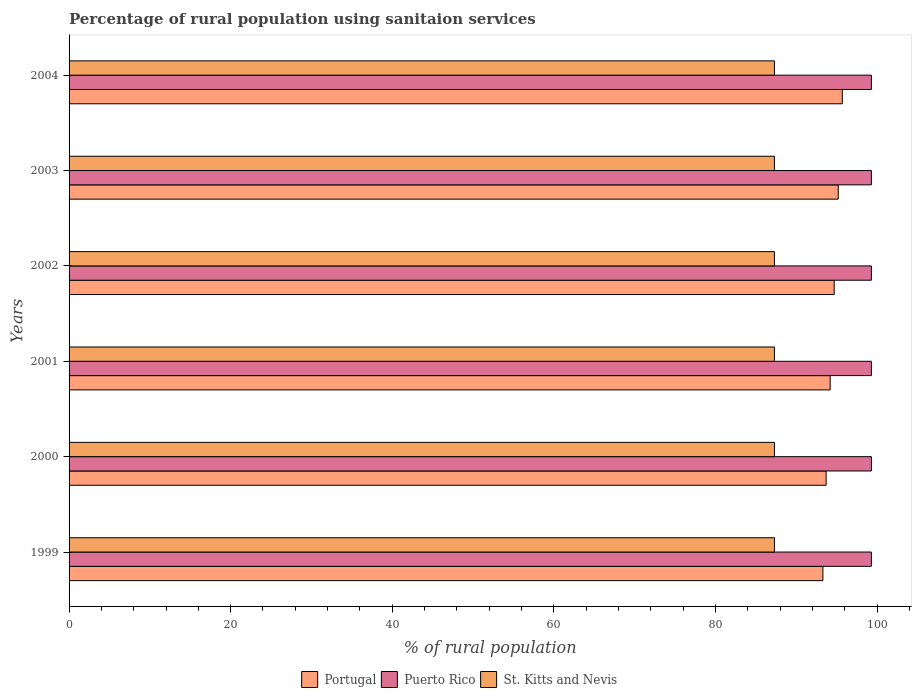How many different coloured bars are there?
Give a very brief answer. 3. How many groups of bars are there?
Your answer should be very brief. 6. Are the number of bars per tick equal to the number of legend labels?
Give a very brief answer. Yes. How many bars are there on the 4th tick from the top?
Provide a succinct answer. 3. In how many cases, is the number of bars for a given year not equal to the number of legend labels?
Offer a very short reply. 0. What is the percentage of rural population using sanitaion services in Portugal in 2002?
Your response must be concise. 94.7. Across all years, what is the maximum percentage of rural population using sanitaion services in Portugal?
Ensure brevity in your answer.  95.7. Across all years, what is the minimum percentage of rural population using sanitaion services in St. Kitts and Nevis?
Make the answer very short. 87.3. In which year was the percentage of rural population using sanitaion services in Puerto Rico minimum?
Keep it short and to the point. 1999. What is the total percentage of rural population using sanitaion services in Puerto Rico in the graph?
Make the answer very short. 595.8. What is the difference between the percentage of rural population using sanitaion services in Portugal in 1999 and that in 2004?
Your answer should be compact. -2.4. What is the difference between the percentage of rural population using sanitaion services in St. Kitts and Nevis in 1999 and the percentage of rural population using sanitaion services in Portugal in 2001?
Ensure brevity in your answer.  -6.9. What is the average percentage of rural population using sanitaion services in Puerto Rico per year?
Offer a terse response. 99.3. In the year 2003, what is the difference between the percentage of rural population using sanitaion services in Portugal and percentage of rural population using sanitaion services in St. Kitts and Nevis?
Your answer should be very brief. 7.9. What is the ratio of the percentage of rural population using sanitaion services in St. Kitts and Nevis in 2001 to that in 2003?
Your answer should be very brief. 1. Is the difference between the percentage of rural population using sanitaion services in Portugal in 1999 and 2003 greater than the difference between the percentage of rural population using sanitaion services in St. Kitts and Nevis in 1999 and 2003?
Ensure brevity in your answer.  No. What is the difference between the highest and the second highest percentage of rural population using sanitaion services in Puerto Rico?
Offer a terse response. 0. What is the difference between the highest and the lowest percentage of rural population using sanitaion services in Portugal?
Give a very brief answer. 2.4. In how many years, is the percentage of rural population using sanitaion services in St. Kitts and Nevis greater than the average percentage of rural population using sanitaion services in St. Kitts and Nevis taken over all years?
Keep it short and to the point. 0. Is the sum of the percentage of rural population using sanitaion services in Portugal in 2000 and 2004 greater than the maximum percentage of rural population using sanitaion services in St. Kitts and Nevis across all years?
Ensure brevity in your answer.  Yes. What does the 1st bar from the top in 2003 represents?
Offer a very short reply. St. Kitts and Nevis. What does the 1st bar from the bottom in 2003 represents?
Keep it short and to the point. Portugal. Is it the case that in every year, the sum of the percentage of rural population using sanitaion services in Portugal and percentage of rural population using sanitaion services in Puerto Rico is greater than the percentage of rural population using sanitaion services in St. Kitts and Nevis?
Keep it short and to the point. Yes. How many bars are there?
Your answer should be compact. 18. How many years are there in the graph?
Make the answer very short. 6. What is the difference between two consecutive major ticks on the X-axis?
Your response must be concise. 20. How are the legend labels stacked?
Provide a short and direct response. Horizontal. What is the title of the graph?
Your response must be concise. Percentage of rural population using sanitaion services. What is the label or title of the X-axis?
Keep it short and to the point. % of rural population. What is the label or title of the Y-axis?
Your answer should be compact. Years. What is the % of rural population of Portugal in 1999?
Your response must be concise. 93.3. What is the % of rural population in Puerto Rico in 1999?
Offer a terse response. 99.3. What is the % of rural population in St. Kitts and Nevis in 1999?
Your response must be concise. 87.3. What is the % of rural population in Portugal in 2000?
Keep it short and to the point. 93.7. What is the % of rural population of Puerto Rico in 2000?
Make the answer very short. 99.3. What is the % of rural population in St. Kitts and Nevis in 2000?
Keep it short and to the point. 87.3. What is the % of rural population in Portugal in 2001?
Make the answer very short. 94.2. What is the % of rural population of Puerto Rico in 2001?
Make the answer very short. 99.3. What is the % of rural population of St. Kitts and Nevis in 2001?
Give a very brief answer. 87.3. What is the % of rural population of Portugal in 2002?
Your answer should be compact. 94.7. What is the % of rural population in Puerto Rico in 2002?
Provide a short and direct response. 99.3. What is the % of rural population of St. Kitts and Nevis in 2002?
Provide a short and direct response. 87.3. What is the % of rural population in Portugal in 2003?
Offer a terse response. 95.2. What is the % of rural population of Puerto Rico in 2003?
Ensure brevity in your answer.  99.3. What is the % of rural population of St. Kitts and Nevis in 2003?
Ensure brevity in your answer.  87.3. What is the % of rural population of Portugal in 2004?
Make the answer very short. 95.7. What is the % of rural population in Puerto Rico in 2004?
Give a very brief answer. 99.3. What is the % of rural population of St. Kitts and Nevis in 2004?
Offer a very short reply. 87.3. Across all years, what is the maximum % of rural population of Portugal?
Provide a succinct answer. 95.7. Across all years, what is the maximum % of rural population of Puerto Rico?
Your answer should be compact. 99.3. Across all years, what is the maximum % of rural population in St. Kitts and Nevis?
Your answer should be compact. 87.3. Across all years, what is the minimum % of rural population of Portugal?
Provide a succinct answer. 93.3. Across all years, what is the minimum % of rural population of Puerto Rico?
Offer a very short reply. 99.3. Across all years, what is the minimum % of rural population in St. Kitts and Nevis?
Give a very brief answer. 87.3. What is the total % of rural population in Portugal in the graph?
Provide a short and direct response. 566.8. What is the total % of rural population in Puerto Rico in the graph?
Offer a very short reply. 595.8. What is the total % of rural population in St. Kitts and Nevis in the graph?
Ensure brevity in your answer.  523.8. What is the difference between the % of rural population of Portugal in 1999 and that in 2000?
Ensure brevity in your answer.  -0.4. What is the difference between the % of rural population of Puerto Rico in 1999 and that in 2000?
Keep it short and to the point. 0. What is the difference between the % of rural population in Portugal in 1999 and that in 2001?
Your answer should be compact. -0.9. What is the difference between the % of rural population of Portugal in 1999 and that in 2002?
Your answer should be very brief. -1.4. What is the difference between the % of rural population in Puerto Rico in 1999 and that in 2002?
Your answer should be compact. 0. What is the difference between the % of rural population in Portugal in 1999 and that in 2004?
Make the answer very short. -2.4. What is the difference between the % of rural population in St. Kitts and Nevis in 1999 and that in 2004?
Your response must be concise. 0. What is the difference between the % of rural population of Puerto Rico in 2000 and that in 2001?
Your answer should be compact. 0. What is the difference between the % of rural population in St. Kitts and Nevis in 2000 and that in 2001?
Make the answer very short. 0. What is the difference between the % of rural population of Puerto Rico in 2000 and that in 2002?
Provide a succinct answer. 0. What is the difference between the % of rural population in St. Kitts and Nevis in 2000 and that in 2003?
Give a very brief answer. 0. What is the difference between the % of rural population in Portugal in 2000 and that in 2004?
Ensure brevity in your answer.  -2. What is the difference between the % of rural population of Puerto Rico in 2000 and that in 2004?
Your response must be concise. 0. What is the difference between the % of rural population in St. Kitts and Nevis in 2000 and that in 2004?
Give a very brief answer. 0. What is the difference between the % of rural population of Portugal in 2001 and that in 2002?
Provide a succinct answer. -0.5. What is the difference between the % of rural population of Puerto Rico in 2001 and that in 2002?
Your answer should be very brief. 0. What is the difference between the % of rural population in Puerto Rico in 2001 and that in 2003?
Your answer should be very brief. 0. What is the difference between the % of rural population in St. Kitts and Nevis in 2001 and that in 2003?
Ensure brevity in your answer.  0. What is the difference between the % of rural population of Puerto Rico in 2001 and that in 2004?
Your answer should be compact. 0. What is the difference between the % of rural population in Puerto Rico in 2002 and that in 2003?
Your answer should be compact. 0. What is the difference between the % of rural population in St. Kitts and Nevis in 2002 and that in 2003?
Keep it short and to the point. 0. What is the difference between the % of rural population of Puerto Rico in 2002 and that in 2004?
Give a very brief answer. 0. What is the difference between the % of rural population of Portugal in 2003 and that in 2004?
Your answer should be compact. -0.5. What is the difference between the % of rural population of Puerto Rico in 2003 and that in 2004?
Offer a very short reply. 0. What is the difference between the % of rural population in Portugal in 1999 and the % of rural population in Puerto Rico in 2000?
Provide a succinct answer. -6. What is the difference between the % of rural population of Puerto Rico in 1999 and the % of rural population of St. Kitts and Nevis in 2000?
Make the answer very short. 12. What is the difference between the % of rural population of Portugal in 1999 and the % of rural population of Puerto Rico in 2001?
Your answer should be compact. -6. What is the difference between the % of rural population in Portugal in 1999 and the % of rural population in St. Kitts and Nevis in 2001?
Make the answer very short. 6. What is the difference between the % of rural population in Puerto Rico in 1999 and the % of rural population in St. Kitts and Nevis in 2002?
Make the answer very short. 12. What is the difference between the % of rural population of Portugal in 1999 and the % of rural population of Puerto Rico in 2003?
Make the answer very short. -6. What is the difference between the % of rural population in Portugal in 1999 and the % of rural population in St. Kitts and Nevis in 2003?
Keep it short and to the point. 6. What is the difference between the % of rural population in Puerto Rico in 1999 and the % of rural population in St. Kitts and Nevis in 2003?
Keep it short and to the point. 12. What is the difference between the % of rural population of Portugal in 1999 and the % of rural population of Puerto Rico in 2004?
Offer a very short reply. -6. What is the difference between the % of rural population in Portugal in 2000 and the % of rural population in Puerto Rico in 2001?
Provide a short and direct response. -5.6. What is the difference between the % of rural population of Portugal in 2000 and the % of rural population of St. Kitts and Nevis in 2001?
Offer a very short reply. 6.4. What is the difference between the % of rural population in Puerto Rico in 2000 and the % of rural population in St. Kitts and Nevis in 2001?
Your answer should be compact. 12. What is the difference between the % of rural population in Portugal in 2000 and the % of rural population in Puerto Rico in 2002?
Your answer should be very brief. -5.6. What is the difference between the % of rural population in Puerto Rico in 2000 and the % of rural population in St. Kitts and Nevis in 2002?
Keep it short and to the point. 12. What is the difference between the % of rural population of Portugal in 2000 and the % of rural population of Puerto Rico in 2003?
Your response must be concise. -5.6. What is the difference between the % of rural population of Portugal in 2000 and the % of rural population of Puerto Rico in 2004?
Ensure brevity in your answer.  -5.6. What is the difference between the % of rural population in Portugal in 2000 and the % of rural population in St. Kitts and Nevis in 2004?
Your answer should be compact. 6.4. What is the difference between the % of rural population in Portugal in 2001 and the % of rural population in Puerto Rico in 2003?
Your answer should be very brief. -5.1. What is the difference between the % of rural population in Puerto Rico in 2001 and the % of rural population in St. Kitts and Nevis in 2003?
Offer a terse response. 12. What is the difference between the % of rural population in Portugal in 2001 and the % of rural population in St. Kitts and Nevis in 2004?
Your answer should be compact. 6.9. What is the difference between the % of rural population of Portugal in 2002 and the % of rural population of St. Kitts and Nevis in 2003?
Provide a succinct answer. 7.4. What is the difference between the % of rural population in Portugal in 2002 and the % of rural population in Puerto Rico in 2004?
Your response must be concise. -4.6. What is the difference between the % of rural population of Puerto Rico in 2002 and the % of rural population of St. Kitts and Nevis in 2004?
Ensure brevity in your answer.  12. What is the difference between the % of rural population of Portugal in 2003 and the % of rural population of Puerto Rico in 2004?
Your answer should be very brief. -4.1. What is the difference between the % of rural population in Portugal in 2003 and the % of rural population in St. Kitts and Nevis in 2004?
Ensure brevity in your answer.  7.9. What is the average % of rural population of Portugal per year?
Provide a short and direct response. 94.47. What is the average % of rural population in Puerto Rico per year?
Your answer should be compact. 99.3. What is the average % of rural population of St. Kitts and Nevis per year?
Your response must be concise. 87.3. In the year 2000, what is the difference between the % of rural population in Portugal and % of rural population in St. Kitts and Nevis?
Provide a succinct answer. 6.4. In the year 2000, what is the difference between the % of rural population of Puerto Rico and % of rural population of St. Kitts and Nevis?
Offer a terse response. 12. In the year 2001, what is the difference between the % of rural population of Puerto Rico and % of rural population of St. Kitts and Nevis?
Provide a succinct answer. 12. In the year 2002, what is the difference between the % of rural population in Portugal and % of rural population in Puerto Rico?
Give a very brief answer. -4.6. In the year 2002, what is the difference between the % of rural population in Puerto Rico and % of rural population in St. Kitts and Nevis?
Your answer should be compact. 12. In the year 2003, what is the difference between the % of rural population of Portugal and % of rural population of Puerto Rico?
Give a very brief answer. -4.1. In the year 2003, what is the difference between the % of rural population of Portugal and % of rural population of St. Kitts and Nevis?
Offer a very short reply. 7.9. In the year 2003, what is the difference between the % of rural population of Puerto Rico and % of rural population of St. Kitts and Nevis?
Offer a very short reply. 12. In the year 2004, what is the difference between the % of rural population of Portugal and % of rural population of St. Kitts and Nevis?
Your answer should be very brief. 8.4. What is the ratio of the % of rural population of Portugal in 1999 to that in 2000?
Make the answer very short. 1. What is the ratio of the % of rural population of St. Kitts and Nevis in 1999 to that in 2000?
Provide a short and direct response. 1. What is the ratio of the % of rural population in Portugal in 1999 to that in 2002?
Give a very brief answer. 0.99. What is the ratio of the % of rural population of Portugal in 1999 to that in 2004?
Provide a succinct answer. 0.97. What is the ratio of the % of rural population of St. Kitts and Nevis in 1999 to that in 2004?
Keep it short and to the point. 1. What is the ratio of the % of rural population of St. Kitts and Nevis in 2000 to that in 2002?
Offer a terse response. 1. What is the ratio of the % of rural population of Portugal in 2000 to that in 2003?
Make the answer very short. 0.98. What is the ratio of the % of rural population of St. Kitts and Nevis in 2000 to that in 2003?
Keep it short and to the point. 1. What is the ratio of the % of rural population in Portugal in 2000 to that in 2004?
Your response must be concise. 0.98. What is the ratio of the % of rural population of Puerto Rico in 2000 to that in 2004?
Make the answer very short. 1. What is the ratio of the % of rural population of St. Kitts and Nevis in 2001 to that in 2002?
Offer a terse response. 1. What is the ratio of the % of rural population in Portugal in 2001 to that in 2003?
Your answer should be compact. 0.99. What is the ratio of the % of rural population of Puerto Rico in 2001 to that in 2003?
Make the answer very short. 1. What is the ratio of the % of rural population of Portugal in 2001 to that in 2004?
Make the answer very short. 0.98. What is the ratio of the % of rural population of St. Kitts and Nevis in 2001 to that in 2004?
Provide a succinct answer. 1. What is the ratio of the % of rural population in Puerto Rico in 2002 to that in 2003?
Give a very brief answer. 1. What is the ratio of the % of rural population in St. Kitts and Nevis in 2002 to that in 2003?
Give a very brief answer. 1. What is the ratio of the % of rural population of Portugal in 2002 to that in 2004?
Your response must be concise. 0.99. What is the ratio of the % of rural population of St. Kitts and Nevis in 2002 to that in 2004?
Your answer should be compact. 1. What is the ratio of the % of rural population in Portugal in 2003 to that in 2004?
Give a very brief answer. 0.99. What is the ratio of the % of rural population of Puerto Rico in 2003 to that in 2004?
Your answer should be compact. 1. What is the difference between the highest and the lowest % of rural population in Puerto Rico?
Ensure brevity in your answer.  0. 